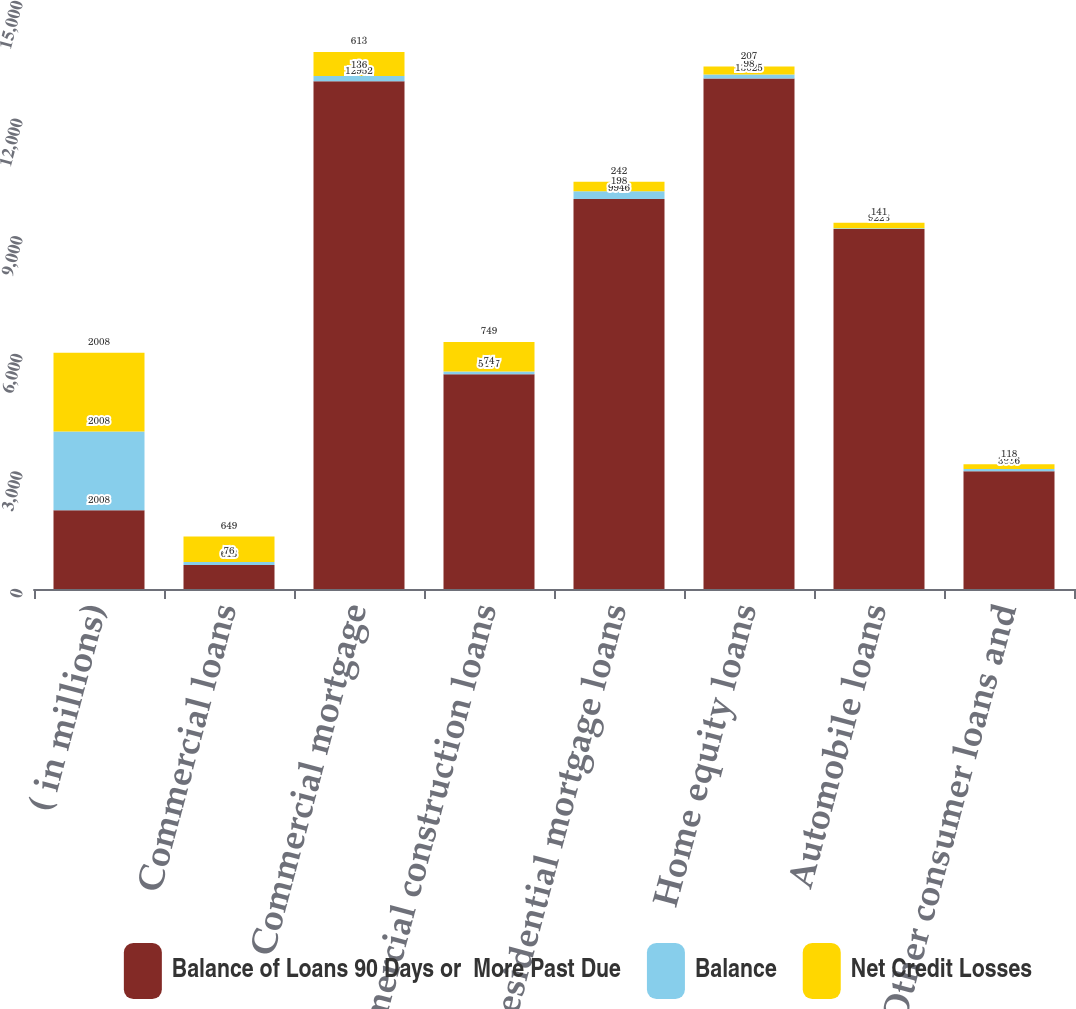Convert chart. <chart><loc_0><loc_0><loc_500><loc_500><stacked_bar_chart><ecel><fcel>( in millions)<fcel>Commercial loans<fcel>Commercial mortgage<fcel>Commercial construction loans<fcel>Residential mortgage loans<fcel>Home equity loans<fcel>Automobile loans<fcel>Other consumer loans and<nl><fcel>Balance of Loans 90 Days or  More Past Due<fcel>2008<fcel>613<fcel>12952<fcel>5477<fcel>9946<fcel>13025<fcel>9183<fcel>3006<nl><fcel>Balance<fcel>2008<fcel>76<fcel>136<fcel>74<fcel>198<fcel>98<fcel>22<fcel>57<nl><fcel>Net Credit Losses<fcel>2008<fcel>649<fcel>613<fcel>749<fcel>242<fcel>207<fcel>141<fcel>118<nl></chart> 